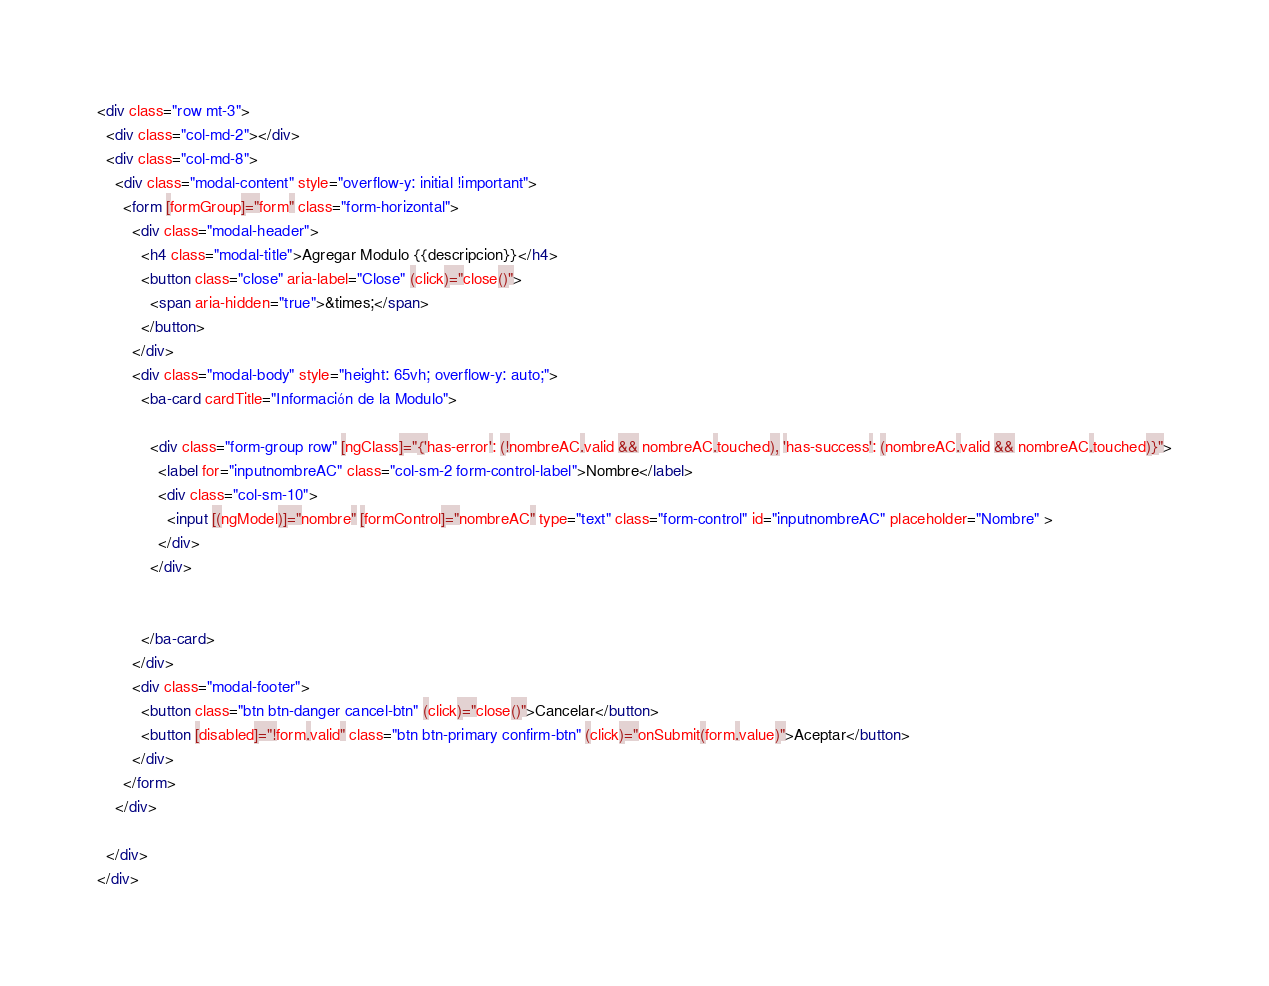Convert code to text. <code><loc_0><loc_0><loc_500><loc_500><_HTML_><div class="row mt-3">
  <div class="col-md-2"></div>
  <div class="col-md-8">
    <div class="modal-content" style="overflow-y: initial !important">
      <form [formGroup]="form" class="form-horizontal">
        <div class="modal-header">
          <h4 class="modal-title">Agregar Modulo {{descripcion}}</h4>
          <button class="close" aria-label="Close" (click)="close()">
            <span aria-hidden="true">&times;</span>
          </button>
        </div>
        <div class="modal-body" style="height: 65vh; overflow-y: auto;">
          <ba-card cardTitle="Información de la Modulo">

            <div class="form-group row" [ngClass]="{'has-error': (!nombreAC.valid && nombreAC.touched), 'has-success': (nombreAC.valid && nombreAC.touched)}">
              <label for="inputnombreAC" class="col-sm-2 form-control-label">Nombre</label>
              <div class="col-sm-10">
                <input [(ngModel)]="nombre" [formControl]="nombreAC" type="text" class="form-control" id="inputnombreAC" placeholder="Nombre" >
              </div>
            </div>


          </ba-card>
        </div>
        <div class="modal-footer">
          <button class="btn btn-danger cancel-btn" (click)="close()">Cancelar</button>
          <button [disabled]="!form.valid" class="btn btn-primary confirm-btn" (click)="onSubmit(form.value)">Aceptar</button>
        </div>
      </form>
    </div>

  </div>
</div>
</code> 